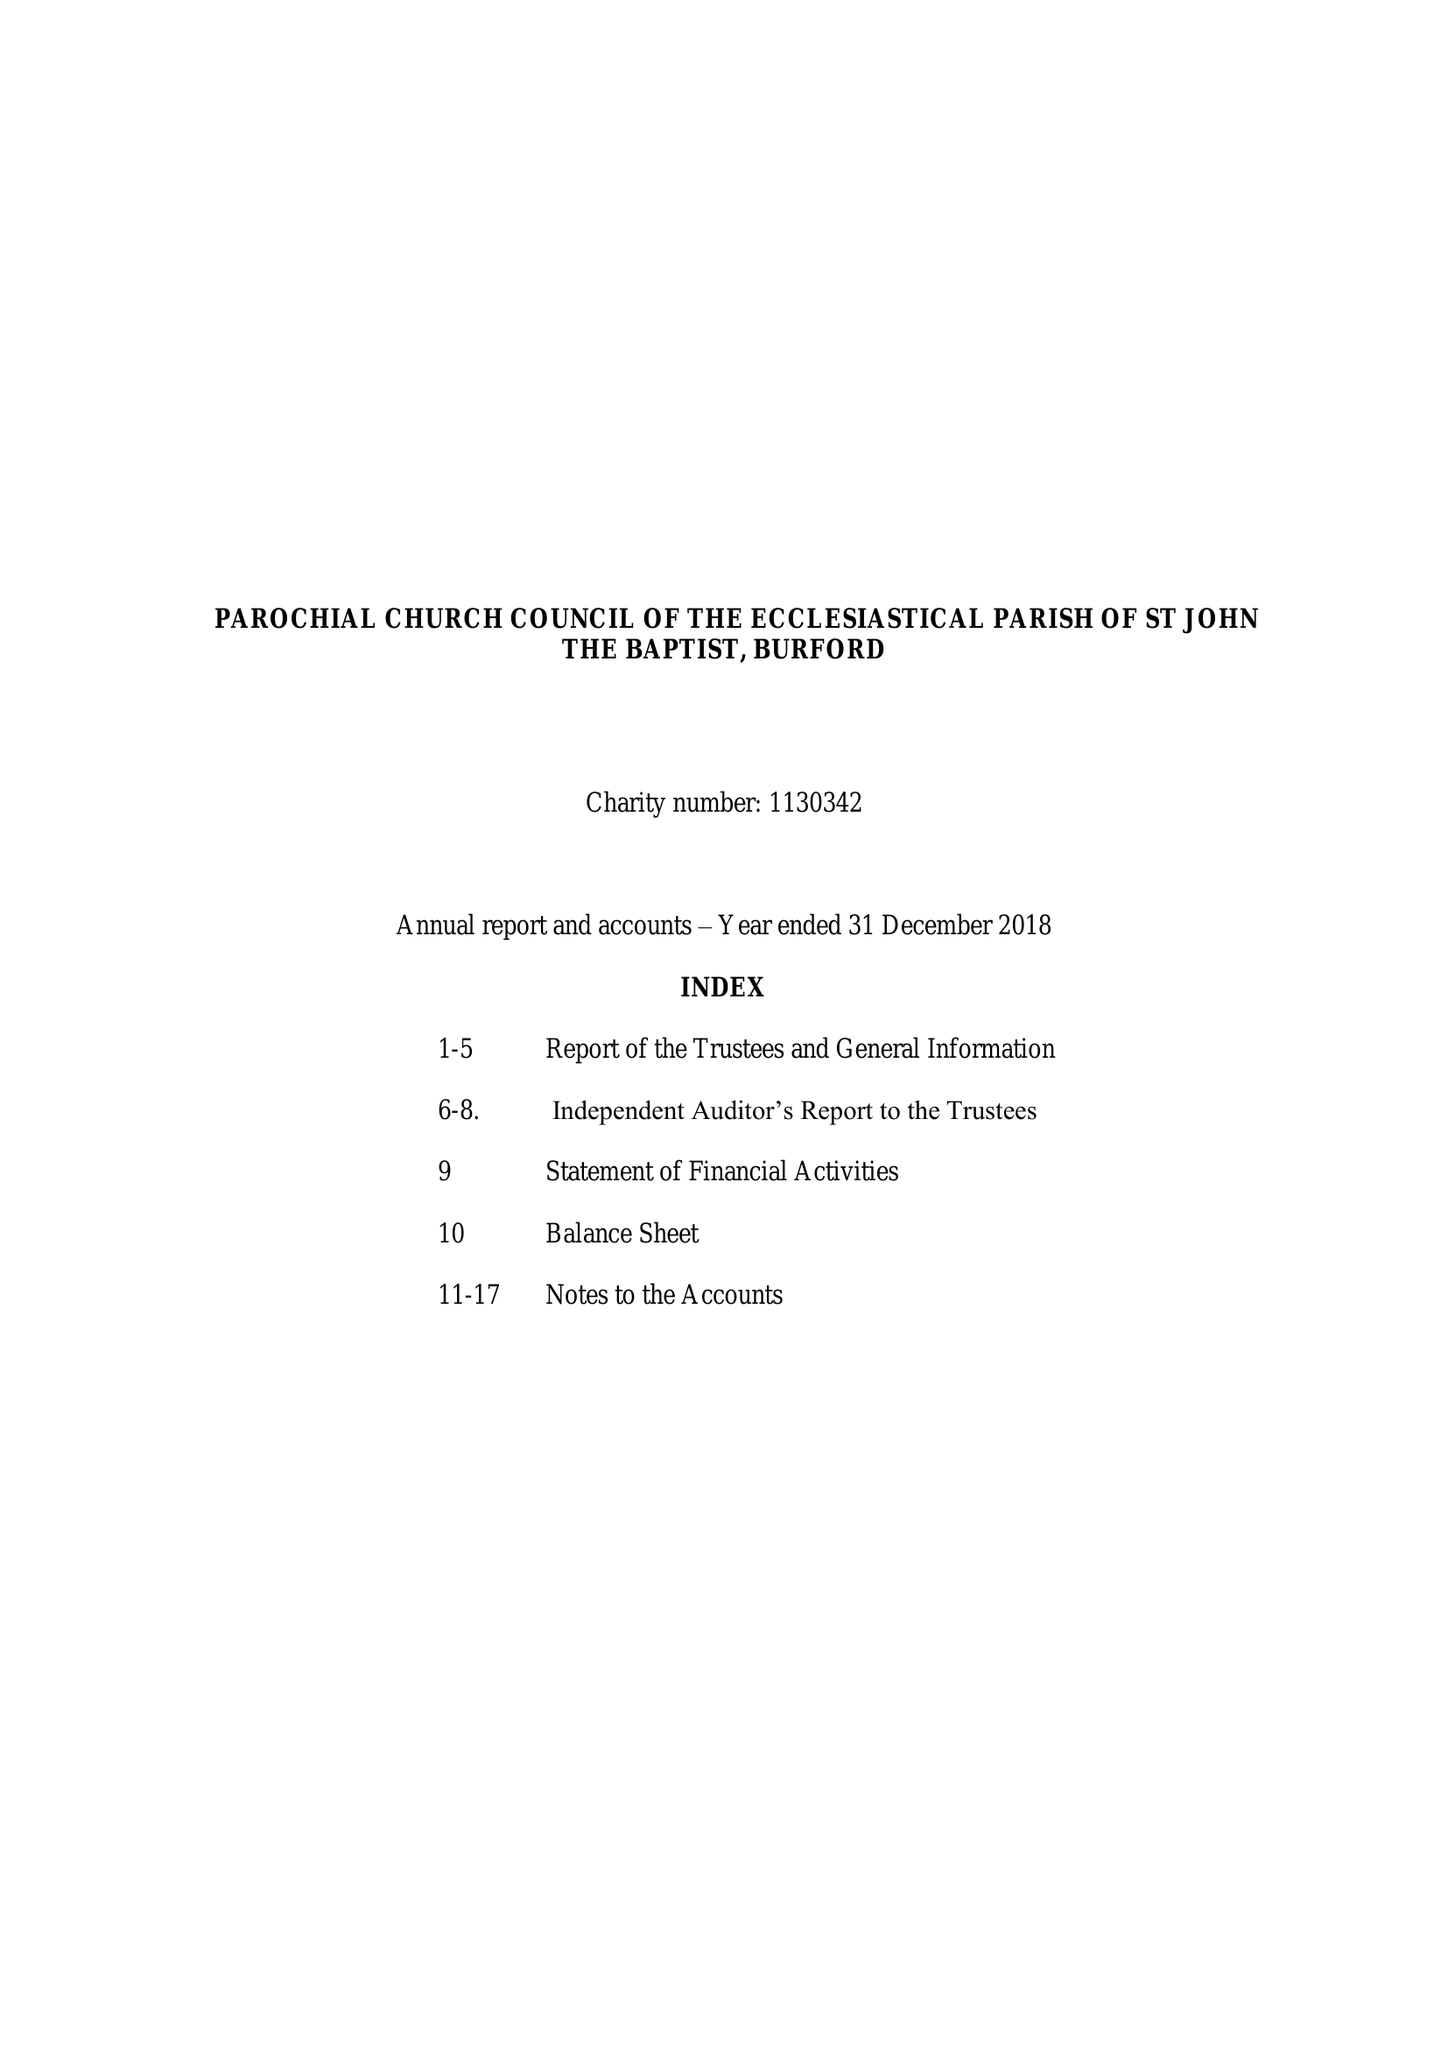What is the value for the address__postcode?
Answer the question using a single word or phrase. OX18 4RZ 